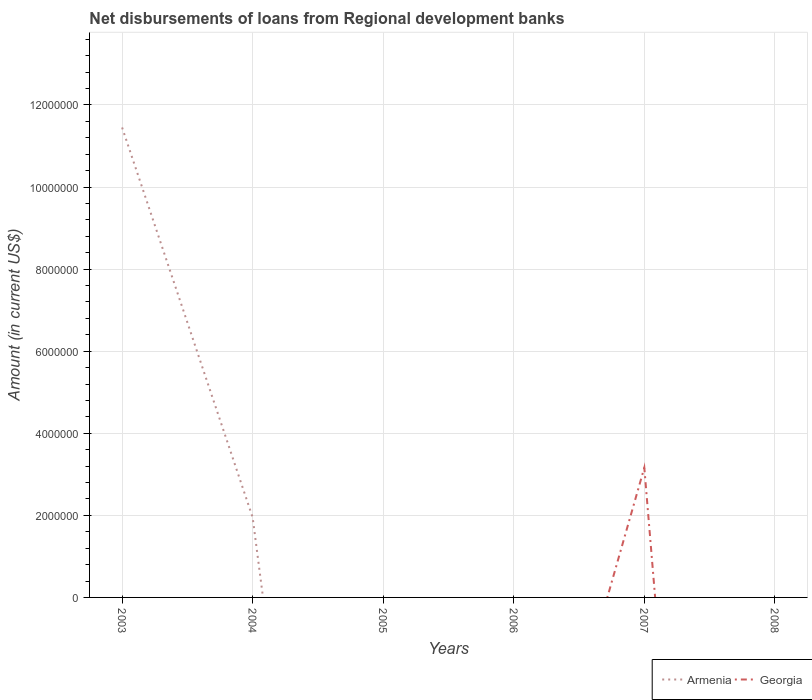How many different coloured lines are there?
Your answer should be very brief. 2. Is the number of lines equal to the number of legend labels?
Your answer should be compact. No. What is the difference between the highest and the second highest amount of disbursements of loans from regional development banks in Armenia?
Offer a very short reply. 1.15e+07. Is the amount of disbursements of loans from regional development banks in Armenia strictly greater than the amount of disbursements of loans from regional development banks in Georgia over the years?
Offer a very short reply. No. How many lines are there?
Your answer should be very brief. 2. What is the difference between two consecutive major ticks on the Y-axis?
Ensure brevity in your answer.  2.00e+06. Does the graph contain any zero values?
Provide a succinct answer. Yes. How are the legend labels stacked?
Give a very brief answer. Horizontal. What is the title of the graph?
Provide a short and direct response. Net disbursements of loans from Regional development banks. Does "Kazakhstan" appear as one of the legend labels in the graph?
Your answer should be very brief. No. What is the label or title of the X-axis?
Keep it short and to the point. Years. What is the label or title of the Y-axis?
Offer a very short reply. Amount (in current US$). What is the Amount (in current US$) in Armenia in 2003?
Give a very brief answer. 1.15e+07. What is the Amount (in current US$) in Georgia in 2003?
Your answer should be very brief. 0. What is the Amount (in current US$) in Armenia in 2004?
Keep it short and to the point. 1.95e+06. What is the Amount (in current US$) in Georgia in 2005?
Your answer should be very brief. 0. What is the Amount (in current US$) of Armenia in 2006?
Provide a short and direct response. 0. What is the Amount (in current US$) in Georgia in 2006?
Your answer should be very brief. 0. What is the Amount (in current US$) of Georgia in 2007?
Your response must be concise. 3.16e+06. What is the Amount (in current US$) of Armenia in 2008?
Make the answer very short. 0. What is the Amount (in current US$) of Georgia in 2008?
Provide a succinct answer. 0. Across all years, what is the maximum Amount (in current US$) of Armenia?
Provide a short and direct response. 1.15e+07. Across all years, what is the maximum Amount (in current US$) in Georgia?
Provide a succinct answer. 3.16e+06. Across all years, what is the minimum Amount (in current US$) of Armenia?
Make the answer very short. 0. Across all years, what is the minimum Amount (in current US$) of Georgia?
Make the answer very short. 0. What is the total Amount (in current US$) of Armenia in the graph?
Your response must be concise. 1.34e+07. What is the total Amount (in current US$) of Georgia in the graph?
Provide a succinct answer. 3.16e+06. What is the difference between the Amount (in current US$) in Armenia in 2003 and that in 2004?
Offer a terse response. 9.50e+06. What is the difference between the Amount (in current US$) in Armenia in 2003 and the Amount (in current US$) in Georgia in 2007?
Make the answer very short. 8.29e+06. What is the difference between the Amount (in current US$) in Armenia in 2004 and the Amount (in current US$) in Georgia in 2007?
Provide a succinct answer. -1.21e+06. What is the average Amount (in current US$) in Armenia per year?
Make the answer very short. 2.23e+06. What is the average Amount (in current US$) of Georgia per year?
Your answer should be very brief. 5.27e+05. What is the ratio of the Amount (in current US$) of Armenia in 2003 to that in 2004?
Offer a terse response. 5.88. What is the difference between the highest and the lowest Amount (in current US$) in Armenia?
Give a very brief answer. 1.15e+07. What is the difference between the highest and the lowest Amount (in current US$) of Georgia?
Give a very brief answer. 3.16e+06. 